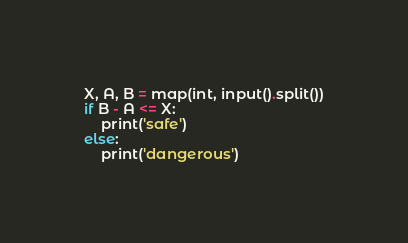<code> <loc_0><loc_0><loc_500><loc_500><_Python_>X, A, B = map(int, input().split())
if B - A <= X:
    print('safe')
else:
    print('dangerous')</code> 